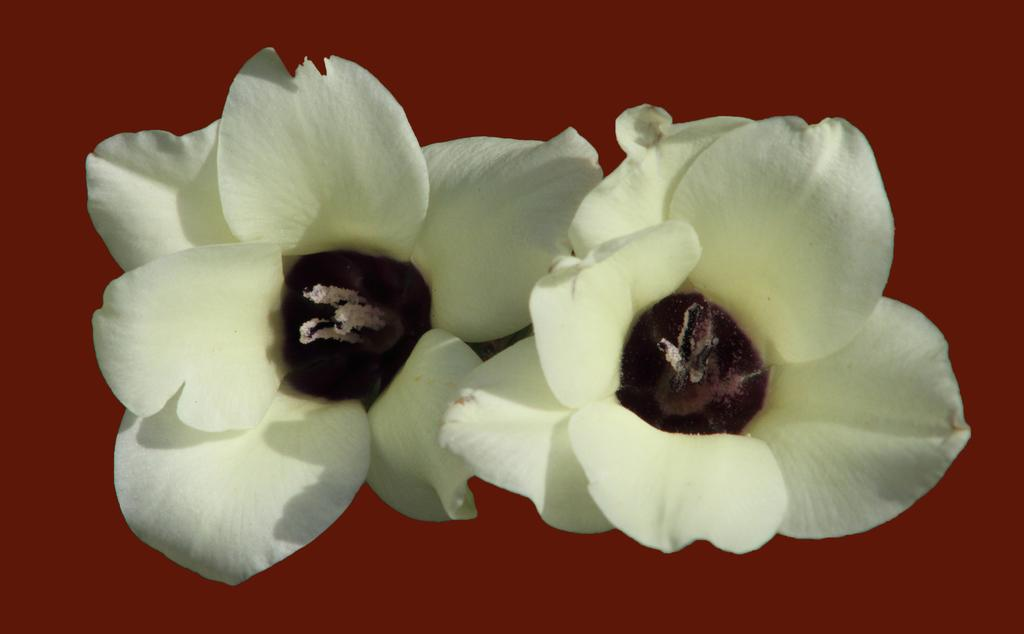What type of living organisms can be seen in the image? There are flowers in the image. What color is the background of the image? The background of the image is red. How many fingers can be seen holding the flowers in the image? There are no fingers or hands visible in the image; it only features flowers and a red background. 